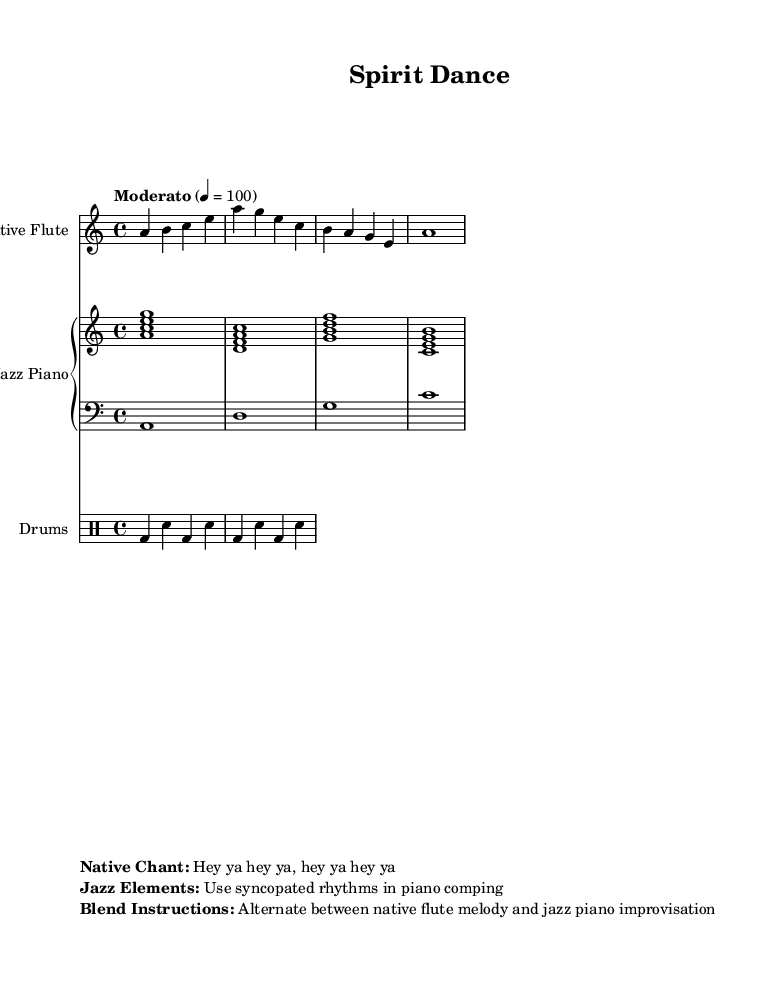What is the key signature of this music? The key signature is A minor, which features one sharp (G#) and no flats. This is evident from the notation which shows the notes are centered around the A and C notes, characteristic of A minor.
Answer: A minor What is the time signature of the piece? The time signature is 4/4, as indicated at the beginning of the score. This means there are four beats in each measure, which is supported by how the rhythms are grouped in the measures.
Answer: 4/4 What is the tempo marking for this piece? The tempo marking is Moderato, which is typically interpreted as moderately fast. This gives insight into the speed at which the piece should be performed.
Answer: Moderato How many measures does the native flute part contain? The native flute part contains four measures. Counting the measures in the flute staff shows a total of four separated by vertical lines.
Answer: Four What elements are suggested for blending native and jazz styles? The blend instructions suggest alternating between the native flute melody and jazz piano improvisation. This emphasizes the fusion of the two genres by intertwining their respective styles.
Answer: Alternate between them What type of rhythmic pattern is indicated for the jazz piano? The jazz piano part indicates the use of minor and major seventh chords, which are typical in jazz music, suggesting a harmonically rich and syncopated style.
Answer: Syncopated rhythms How is the drum pattern structured in this piece? The drum pattern is structured with bass drum and snare hits; each measure consists of alternating notes in a simple but effective rhythmic pattern, characteristic of jazz drumming.
Answer: Alternating bass and snare 